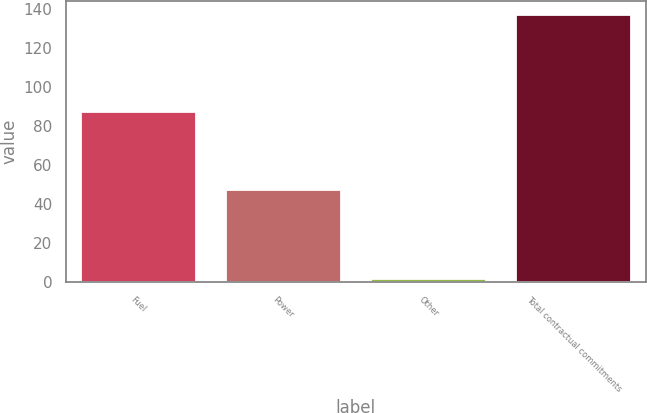<chart> <loc_0><loc_0><loc_500><loc_500><bar_chart><fcel>Fuel<fcel>Power<fcel>Other<fcel>Total contractual commitments<nl><fcel>87.5<fcel>47.8<fcel>2.1<fcel>137.4<nl></chart> 